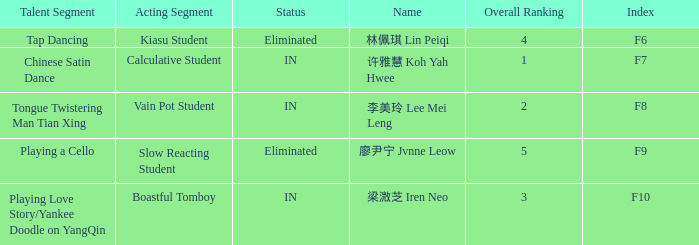For all events with index f10, what is the sum of the overall rankings? 3.0. 